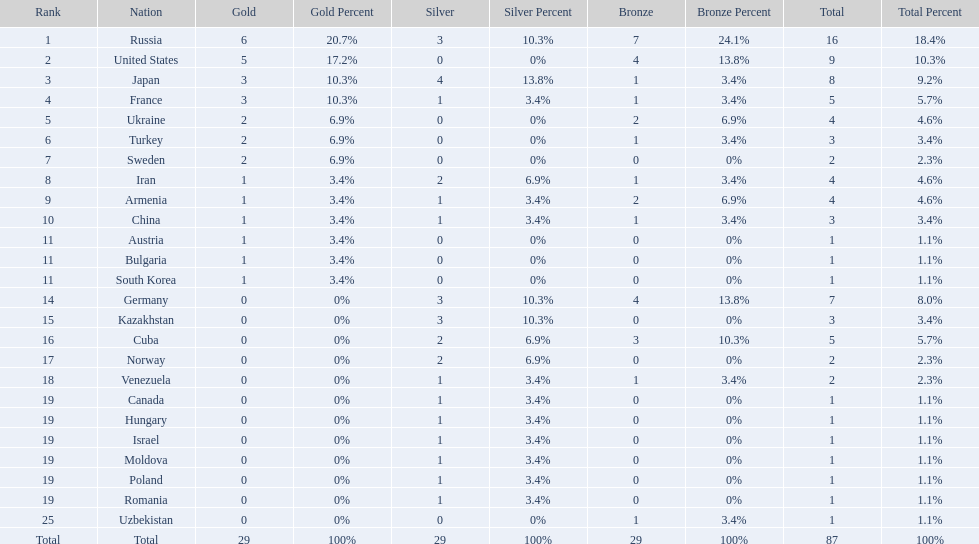How many combined gold medals did japan and france win? 6. 